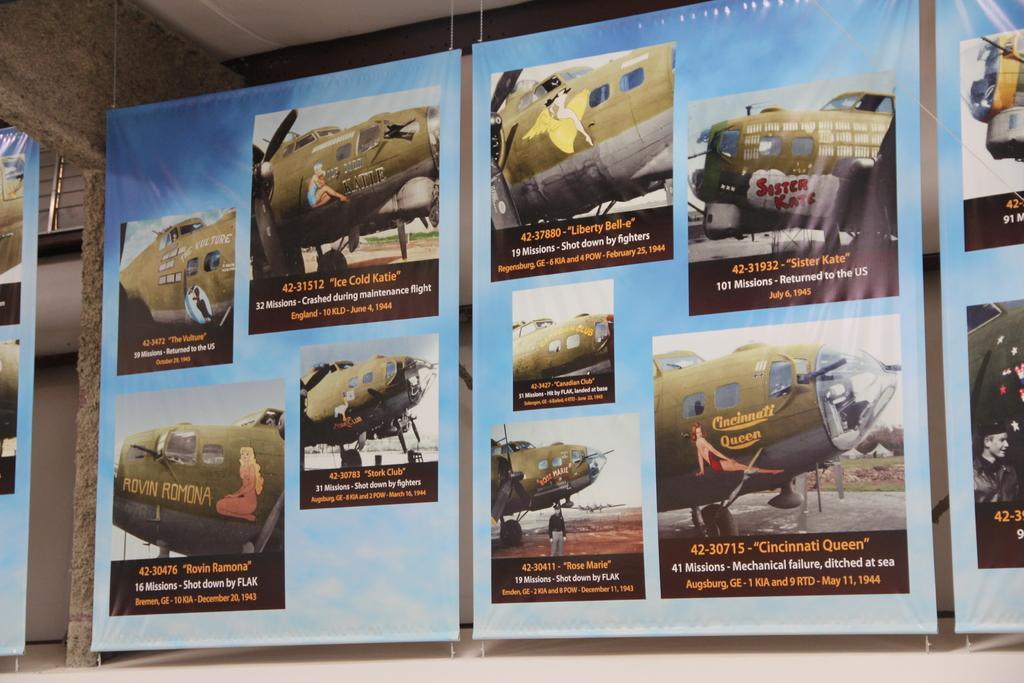What is the main subject of the image? The main subject of the image is aircrafts. Are there any people present in the image? Yes, there are people in the image. What else can be seen in the image besides aircrafts and people? There are banners with text in the image. Can you describe the setting of the image? The image shows a roof at the top and a floor at the bottom, suggesting an indoor or enclosed space. How many teeth can be seen on the aircraft in the image? There are no teeth visible on the aircraft in the image, as aircrafts do not have teeth. 